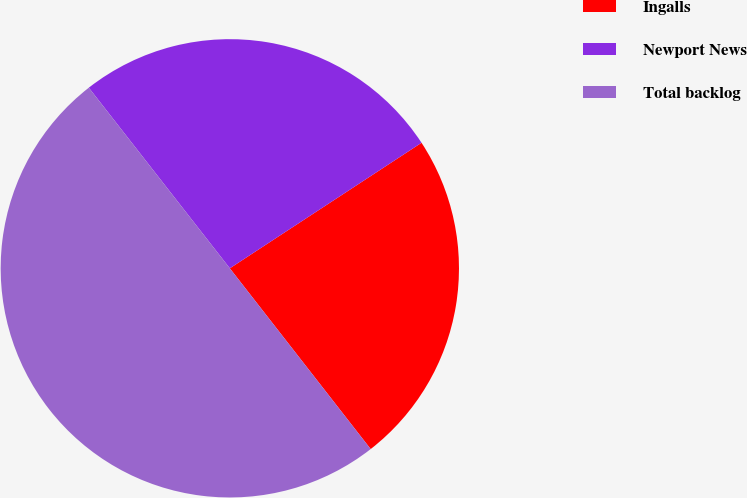Convert chart to OTSL. <chart><loc_0><loc_0><loc_500><loc_500><pie_chart><fcel>Ingalls<fcel>Newport News<fcel>Total backlog<nl><fcel>23.69%<fcel>26.32%<fcel>49.98%<nl></chart> 